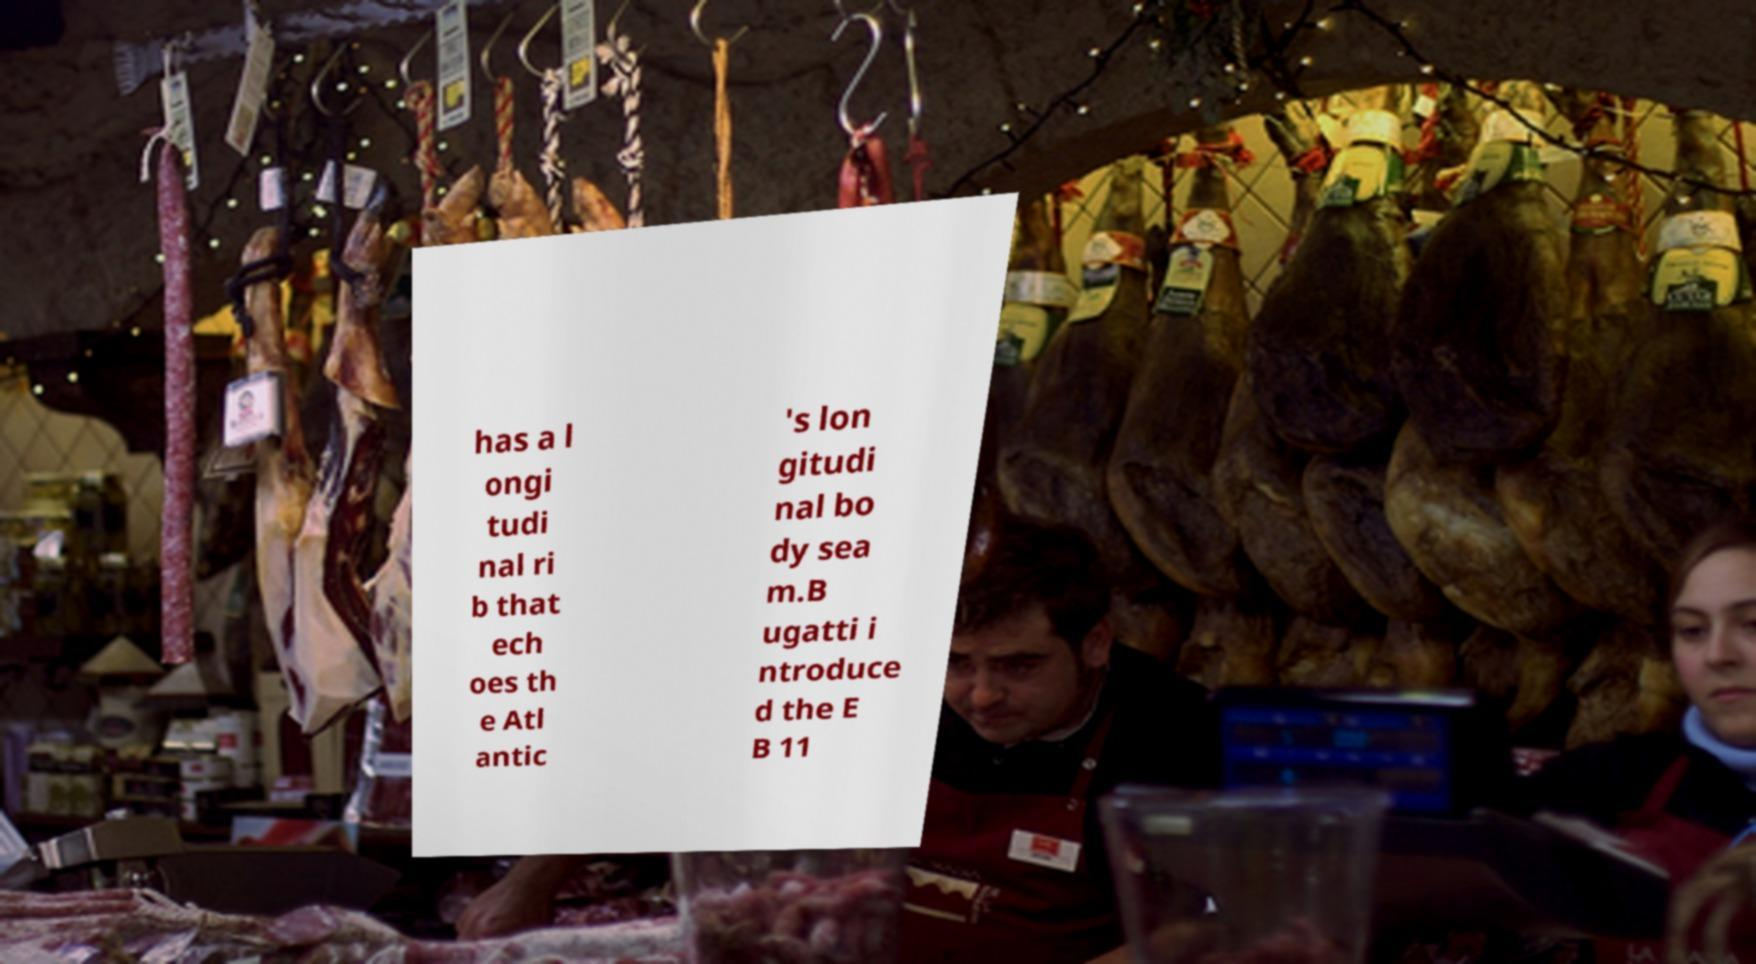For documentation purposes, I need the text within this image transcribed. Could you provide that? has a l ongi tudi nal ri b that ech oes th e Atl antic 's lon gitudi nal bo dy sea m.B ugatti i ntroduce d the E B 11 